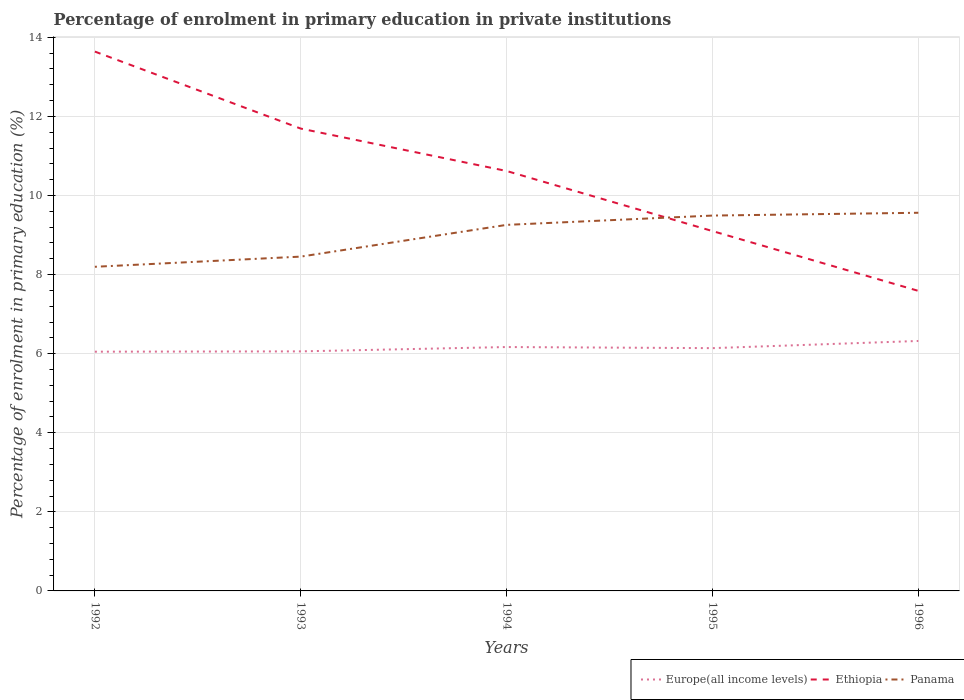Across all years, what is the maximum percentage of enrolment in primary education in Ethiopia?
Offer a terse response. 7.59. What is the total percentage of enrolment in primary education in Ethiopia in the graph?
Make the answer very short. 6.05. What is the difference between the highest and the second highest percentage of enrolment in primary education in Panama?
Your answer should be compact. 1.37. What is the difference between the highest and the lowest percentage of enrolment in primary education in Europe(all income levels)?
Your answer should be compact. 2. How many years are there in the graph?
Offer a very short reply. 5. Are the values on the major ticks of Y-axis written in scientific E-notation?
Your response must be concise. No. Does the graph contain grids?
Your answer should be compact. Yes. Where does the legend appear in the graph?
Keep it short and to the point. Bottom right. How are the legend labels stacked?
Offer a terse response. Horizontal. What is the title of the graph?
Provide a succinct answer. Percentage of enrolment in primary education in private institutions. What is the label or title of the Y-axis?
Keep it short and to the point. Percentage of enrolment in primary education (%). What is the Percentage of enrolment in primary education (%) in Europe(all income levels) in 1992?
Ensure brevity in your answer.  6.05. What is the Percentage of enrolment in primary education (%) in Ethiopia in 1992?
Your answer should be compact. 13.64. What is the Percentage of enrolment in primary education (%) in Panama in 1992?
Your answer should be compact. 8.2. What is the Percentage of enrolment in primary education (%) in Europe(all income levels) in 1993?
Your answer should be compact. 6.06. What is the Percentage of enrolment in primary education (%) of Ethiopia in 1993?
Keep it short and to the point. 11.69. What is the Percentage of enrolment in primary education (%) in Panama in 1993?
Ensure brevity in your answer.  8.45. What is the Percentage of enrolment in primary education (%) of Europe(all income levels) in 1994?
Your response must be concise. 6.17. What is the Percentage of enrolment in primary education (%) of Ethiopia in 1994?
Provide a succinct answer. 10.62. What is the Percentage of enrolment in primary education (%) of Panama in 1994?
Your answer should be compact. 9.26. What is the Percentage of enrolment in primary education (%) of Europe(all income levels) in 1995?
Make the answer very short. 6.14. What is the Percentage of enrolment in primary education (%) of Ethiopia in 1995?
Offer a very short reply. 9.1. What is the Percentage of enrolment in primary education (%) of Panama in 1995?
Provide a succinct answer. 9.49. What is the Percentage of enrolment in primary education (%) of Europe(all income levels) in 1996?
Your answer should be very brief. 6.32. What is the Percentage of enrolment in primary education (%) in Ethiopia in 1996?
Ensure brevity in your answer.  7.59. What is the Percentage of enrolment in primary education (%) in Panama in 1996?
Provide a succinct answer. 9.56. Across all years, what is the maximum Percentage of enrolment in primary education (%) of Europe(all income levels)?
Keep it short and to the point. 6.32. Across all years, what is the maximum Percentage of enrolment in primary education (%) in Ethiopia?
Offer a terse response. 13.64. Across all years, what is the maximum Percentage of enrolment in primary education (%) in Panama?
Offer a terse response. 9.56. Across all years, what is the minimum Percentage of enrolment in primary education (%) of Europe(all income levels)?
Provide a succinct answer. 6.05. Across all years, what is the minimum Percentage of enrolment in primary education (%) of Ethiopia?
Your answer should be very brief. 7.59. Across all years, what is the minimum Percentage of enrolment in primary education (%) in Panama?
Your response must be concise. 8.2. What is the total Percentage of enrolment in primary education (%) of Europe(all income levels) in the graph?
Your answer should be very brief. 30.74. What is the total Percentage of enrolment in primary education (%) in Ethiopia in the graph?
Ensure brevity in your answer.  52.64. What is the total Percentage of enrolment in primary education (%) in Panama in the graph?
Provide a succinct answer. 44.97. What is the difference between the Percentage of enrolment in primary education (%) of Europe(all income levels) in 1992 and that in 1993?
Give a very brief answer. -0.01. What is the difference between the Percentage of enrolment in primary education (%) in Ethiopia in 1992 and that in 1993?
Provide a short and direct response. 1.95. What is the difference between the Percentage of enrolment in primary education (%) in Panama in 1992 and that in 1993?
Give a very brief answer. -0.26. What is the difference between the Percentage of enrolment in primary education (%) in Europe(all income levels) in 1992 and that in 1994?
Your answer should be very brief. -0.12. What is the difference between the Percentage of enrolment in primary education (%) in Ethiopia in 1992 and that in 1994?
Offer a terse response. 3.02. What is the difference between the Percentage of enrolment in primary education (%) in Panama in 1992 and that in 1994?
Keep it short and to the point. -1.06. What is the difference between the Percentage of enrolment in primary education (%) in Europe(all income levels) in 1992 and that in 1995?
Provide a short and direct response. -0.09. What is the difference between the Percentage of enrolment in primary education (%) of Ethiopia in 1992 and that in 1995?
Your answer should be very brief. 4.54. What is the difference between the Percentage of enrolment in primary education (%) of Panama in 1992 and that in 1995?
Make the answer very short. -1.3. What is the difference between the Percentage of enrolment in primary education (%) of Europe(all income levels) in 1992 and that in 1996?
Provide a succinct answer. -0.27. What is the difference between the Percentage of enrolment in primary education (%) in Ethiopia in 1992 and that in 1996?
Offer a very short reply. 6.05. What is the difference between the Percentage of enrolment in primary education (%) in Panama in 1992 and that in 1996?
Your answer should be very brief. -1.37. What is the difference between the Percentage of enrolment in primary education (%) in Europe(all income levels) in 1993 and that in 1994?
Your response must be concise. -0.11. What is the difference between the Percentage of enrolment in primary education (%) in Ethiopia in 1993 and that in 1994?
Make the answer very short. 1.07. What is the difference between the Percentage of enrolment in primary education (%) in Panama in 1993 and that in 1994?
Your response must be concise. -0.8. What is the difference between the Percentage of enrolment in primary education (%) of Europe(all income levels) in 1993 and that in 1995?
Give a very brief answer. -0.08. What is the difference between the Percentage of enrolment in primary education (%) in Ethiopia in 1993 and that in 1995?
Provide a succinct answer. 2.59. What is the difference between the Percentage of enrolment in primary education (%) in Panama in 1993 and that in 1995?
Give a very brief answer. -1.04. What is the difference between the Percentage of enrolment in primary education (%) of Europe(all income levels) in 1993 and that in 1996?
Make the answer very short. -0.26. What is the difference between the Percentage of enrolment in primary education (%) of Ethiopia in 1993 and that in 1996?
Provide a short and direct response. 4.1. What is the difference between the Percentage of enrolment in primary education (%) of Panama in 1993 and that in 1996?
Your answer should be very brief. -1.11. What is the difference between the Percentage of enrolment in primary education (%) of Europe(all income levels) in 1994 and that in 1995?
Provide a short and direct response. 0.03. What is the difference between the Percentage of enrolment in primary education (%) in Ethiopia in 1994 and that in 1995?
Your answer should be compact. 1.52. What is the difference between the Percentage of enrolment in primary education (%) of Panama in 1994 and that in 1995?
Keep it short and to the point. -0.24. What is the difference between the Percentage of enrolment in primary education (%) of Europe(all income levels) in 1994 and that in 1996?
Offer a terse response. -0.15. What is the difference between the Percentage of enrolment in primary education (%) in Ethiopia in 1994 and that in 1996?
Your response must be concise. 3.03. What is the difference between the Percentage of enrolment in primary education (%) in Panama in 1994 and that in 1996?
Give a very brief answer. -0.31. What is the difference between the Percentage of enrolment in primary education (%) in Europe(all income levels) in 1995 and that in 1996?
Offer a very short reply. -0.18. What is the difference between the Percentage of enrolment in primary education (%) in Ethiopia in 1995 and that in 1996?
Keep it short and to the point. 1.51. What is the difference between the Percentage of enrolment in primary education (%) of Panama in 1995 and that in 1996?
Provide a short and direct response. -0.07. What is the difference between the Percentage of enrolment in primary education (%) of Europe(all income levels) in 1992 and the Percentage of enrolment in primary education (%) of Ethiopia in 1993?
Keep it short and to the point. -5.64. What is the difference between the Percentage of enrolment in primary education (%) in Europe(all income levels) in 1992 and the Percentage of enrolment in primary education (%) in Panama in 1993?
Keep it short and to the point. -2.4. What is the difference between the Percentage of enrolment in primary education (%) of Ethiopia in 1992 and the Percentage of enrolment in primary education (%) of Panama in 1993?
Offer a very short reply. 5.19. What is the difference between the Percentage of enrolment in primary education (%) of Europe(all income levels) in 1992 and the Percentage of enrolment in primary education (%) of Ethiopia in 1994?
Offer a terse response. -4.57. What is the difference between the Percentage of enrolment in primary education (%) of Europe(all income levels) in 1992 and the Percentage of enrolment in primary education (%) of Panama in 1994?
Keep it short and to the point. -3.21. What is the difference between the Percentage of enrolment in primary education (%) of Ethiopia in 1992 and the Percentage of enrolment in primary education (%) of Panama in 1994?
Provide a succinct answer. 4.38. What is the difference between the Percentage of enrolment in primary education (%) in Europe(all income levels) in 1992 and the Percentage of enrolment in primary education (%) in Ethiopia in 1995?
Ensure brevity in your answer.  -3.05. What is the difference between the Percentage of enrolment in primary education (%) in Europe(all income levels) in 1992 and the Percentage of enrolment in primary education (%) in Panama in 1995?
Offer a terse response. -3.44. What is the difference between the Percentage of enrolment in primary education (%) in Ethiopia in 1992 and the Percentage of enrolment in primary education (%) in Panama in 1995?
Give a very brief answer. 4.15. What is the difference between the Percentage of enrolment in primary education (%) of Europe(all income levels) in 1992 and the Percentage of enrolment in primary education (%) of Ethiopia in 1996?
Offer a very short reply. -1.54. What is the difference between the Percentage of enrolment in primary education (%) of Europe(all income levels) in 1992 and the Percentage of enrolment in primary education (%) of Panama in 1996?
Your response must be concise. -3.51. What is the difference between the Percentage of enrolment in primary education (%) in Ethiopia in 1992 and the Percentage of enrolment in primary education (%) in Panama in 1996?
Provide a succinct answer. 4.08. What is the difference between the Percentage of enrolment in primary education (%) in Europe(all income levels) in 1993 and the Percentage of enrolment in primary education (%) in Ethiopia in 1994?
Your response must be concise. -4.56. What is the difference between the Percentage of enrolment in primary education (%) of Europe(all income levels) in 1993 and the Percentage of enrolment in primary education (%) of Panama in 1994?
Offer a terse response. -3.2. What is the difference between the Percentage of enrolment in primary education (%) of Ethiopia in 1993 and the Percentage of enrolment in primary education (%) of Panama in 1994?
Give a very brief answer. 2.44. What is the difference between the Percentage of enrolment in primary education (%) of Europe(all income levels) in 1993 and the Percentage of enrolment in primary education (%) of Ethiopia in 1995?
Your answer should be compact. -3.04. What is the difference between the Percentage of enrolment in primary education (%) in Europe(all income levels) in 1993 and the Percentage of enrolment in primary education (%) in Panama in 1995?
Offer a terse response. -3.43. What is the difference between the Percentage of enrolment in primary education (%) in Ethiopia in 1993 and the Percentage of enrolment in primary education (%) in Panama in 1995?
Your response must be concise. 2.2. What is the difference between the Percentage of enrolment in primary education (%) in Europe(all income levels) in 1993 and the Percentage of enrolment in primary education (%) in Ethiopia in 1996?
Your answer should be very brief. -1.53. What is the difference between the Percentage of enrolment in primary education (%) of Europe(all income levels) in 1993 and the Percentage of enrolment in primary education (%) of Panama in 1996?
Give a very brief answer. -3.51. What is the difference between the Percentage of enrolment in primary education (%) of Ethiopia in 1993 and the Percentage of enrolment in primary education (%) of Panama in 1996?
Give a very brief answer. 2.13. What is the difference between the Percentage of enrolment in primary education (%) in Europe(all income levels) in 1994 and the Percentage of enrolment in primary education (%) in Ethiopia in 1995?
Offer a very short reply. -2.93. What is the difference between the Percentage of enrolment in primary education (%) of Europe(all income levels) in 1994 and the Percentage of enrolment in primary education (%) of Panama in 1995?
Your answer should be compact. -3.32. What is the difference between the Percentage of enrolment in primary education (%) in Ethiopia in 1994 and the Percentage of enrolment in primary education (%) in Panama in 1995?
Give a very brief answer. 1.13. What is the difference between the Percentage of enrolment in primary education (%) of Europe(all income levels) in 1994 and the Percentage of enrolment in primary education (%) of Ethiopia in 1996?
Keep it short and to the point. -1.42. What is the difference between the Percentage of enrolment in primary education (%) of Europe(all income levels) in 1994 and the Percentage of enrolment in primary education (%) of Panama in 1996?
Ensure brevity in your answer.  -3.4. What is the difference between the Percentage of enrolment in primary education (%) in Ethiopia in 1994 and the Percentage of enrolment in primary education (%) in Panama in 1996?
Your response must be concise. 1.06. What is the difference between the Percentage of enrolment in primary education (%) in Europe(all income levels) in 1995 and the Percentage of enrolment in primary education (%) in Ethiopia in 1996?
Offer a terse response. -1.45. What is the difference between the Percentage of enrolment in primary education (%) of Europe(all income levels) in 1995 and the Percentage of enrolment in primary education (%) of Panama in 1996?
Ensure brevity in your answer.  -3.42. What is the difference between the Percentage of enrolment in primary education (%) of Ethiopia in 1995 and the Percentage of enrolment in primary education (%) of Panama in 1996?
Ensure brevity in your answer.  -0.46. What is the average Percentage of enrolment in primary education (%) in Europe(all income levels) per year?
Your answer should be very brief. 6.15. What is the average Percentage of enrolment in primary education (%) of Ethiopia per year?
Ensure brevity in your answer.  10.53. What is the average Percentage of enrolment in primary education (%) in Panama per year?
Ensure brevity in your answer.  8.99. In the year 1992, what is the difference between the Percentage of enrolment in primary education (%) of Europe(all income levels) and Percentage of enrolment in primary education (%) of Ethiopia?
Ensure brevity in your answer.  -7.59. In the year 1992, what is the difference between the Percentage of enrolment in primary education (%) of Europe(all income levels) and Percentage of enrolment in primary education (%) of Panama?
Ensure brevity in your answer.  -2.15. In the year 1992, what is the difference between the Percentage of enrolment in primary education (%) of Ethiopia and Percentage of enrolment in primary education (%) of Panama?
Ensure brevity in your answer.  5.44. In the year 1993, what is the difference between the Percentage of enrolment in primary education (%) of Europe(all income levels) and Percentage of enrolment in primary education (%) of Ethiopia?
Your answer should be very brief. -5.63. In the year 1993, what is the difference between the Percentage of enrolment in primary education (%) of Europe(all income levels) and Percentage of enrolment in primary education (%) of Panama?
Offer a very short reply. -2.4. In the year 1993, what is the difference between the Percentage of enrolment in primary education (%) of Ethiopia and Percentage of enrolment in primary education (%) of Panama?
Provide a succinct answer. 3.24. In the year 1994, what is the difference between the Percentage of enrolment in primary education (%) in Europe(all income levels) and Percentage of enrolment in primary education (%) in Ethiopia?
Make the answer very short. -4.45. In the year 1994, what is the difference between the Percentage of enrolment in primary education (%) of Europe(all income levels) and Percentage of enrolment in primary education (%) of Panama?
Give a very brief answer. -3.09. In the year 1994, what is the difference between the Percentage of enrolment in primary education (%) of Ethiopia and Percentage of enrolment in primary education (%) of Panama?
Offer a very short reply. 1.36. In the year 1995, what is the difference between the Percentage of enrolment in primary education (%) in Europe(all income levels) and Percentage of enrolment in primary education (%) in Ethiopia?
Your response must be concise. -2.96. In the year 1995, what is the difference between the Percentage of enrolment in primary education (%) of Europe(all income levels) and Percentage of enrolment in primary education (%) of Panama?
Ensure brevity in your answer.  -3.35. In the year 1995, what is the difference between the Percentage of enrolment in primary education (%) of Ethiopia and Percentage of enrolment in primary education (%) of Panama?
Provide a short and direct response. -0.39. In the year 1996, what is the difference between the Percentage of enrolment in primary education (%) in Europe(all income levels) and Percentage of enrolment in primary education (%) in Ethiopia?
Offer a terse response. -1.27. In the year 1996, what is the difference between the Percentage of enrolment in primary education (%) of Europe(all income levels) and Percentage of enrolment in primary education (%) of Panama?
Your answer should be very brief. -3.24. In the year 1996, what is the difference between the Percentage of enrolment in primary education (%) in Ethiopia and Percentage of enrolment in primary education (%) in Panama?
Keep it short and to the point. -1.98. What is the ratio of the Percentage of enrolment in primary education (%) of Ethiopia in 1992 to that in 1993?
Provide a succinct answer. 1.17. What is the ratio of the Percentage of enrolment in primary education (%) in Panama in 1992 to that in 1993?
Ensure brevity in your answer.  0.97. What is the ratio of the Percentage of enrolment in primary education (%) in Europe(all income levels) in 1992 to that in 1994?
Offer a terse response. 0.98. What is the ratio of the Percentage of enrolment in primary education (%) of Ethiopia in 1992 to that in 1994?
Your response must be concise. 1.28. What is the ratio of the Percentage of enrolment in primary education (%) in Panama in 1992 to that in 1994?
Give a very brief answer. 0.89. What is the ratio of the Percentage of enrolment in primary education (%) of Europe(all income levels) in 1992 to that in 1995?
Your response must be concise. 0.99. What is the ratio of the Percentage of enrolment in primary education (%) of Ethiopia in 1992 to that in 1995?
Provide a short and direct response. 1.5. What is the ratio of the Percentage of enrolment in primary education (%) of Panama in 1992 to that in 1995?
Provide a succinct answer. 0.86. What is the ratio of the Percentage of enrolment in primary education (%) in Europe(all income levels) in 1992 to that in 1996?
Offer a very short reply. 0.96. What is the ratio of the Percentage of enrolment in primary education (%) in Ethiopia in 1992 to that in 1996?
Provide a short and direct response. 1.8. What is the ratio of the Percentage of enrolment in primary education (%) in Panama in 1992 to that in 1996?
Provide a short and direct response. 0.86. What is the ratio of the Percentage of enrolment in primary education (%) of Europe(all income levels) in 1993 to that in 1994?
Your answer should be compact. 0.98. What is the ratio of the Percentage of enrolment in primary education (%) of Ethiopia in 1993 to that in 1994?
Provide a short and direct response. 1.1. What is the ratio of the Percentage of enrolment in primary education (%) of Panama in 1993 to that in 1994?
Your answer should be very brief. 0.91. What is the ratio of the Percentage of enrolment in primary education (%) in Europe(all income levels) in 1993 to that in 1995?
Keep it short and to the point. 0.99. What is the ratio of the Percentage of enrolment in primary education (%) of Ethiopia in 1993 to that in 1995?
Offer a terse response. 1.28. What is the ratio of the Percentage of enrolment in primary education (%) of Panama in 1993 to that in 1995?
Offer a terse response. 0.89. What is the ratio of the Percentage of enrolment in primary education (%) in Europe(all income levels) in 1993 to that in 1996?
Offer a very short reply. 0.96. What is the ratio of the Percentage of enrolment in primary education (%) of Ethiopia in 1993 to that in 1996?
Your response must be concise. 1.54. What is the ratio of the Percentage of enrolment in primary education (%) in Panama in 1993 to that in 1996?
Your answer should be compact. 0.88. What is the ratio of the Percentage of enrolment in primary education (%) of Europe(all income levels) in 1994 to that in 1995?
Keep it short and to the point. 1. What is the ratio of the Percentage of enrolment in primary education (%) in Ethiopia in 1994 to that in 1995?
Provide a short and direct response. 1.17. What is the ratio of the Percentage of enrolment in primary education (%) of Panama in 1994 to that in 1995?
Make the answer very short. 0.98. What is the ratio of the Percentage of enrolment in primary education (%) of Europe(all income levels) in 1994 to that in 1996?
Your answer should be very brief. 0.98. What is the ratio of the Percentage of enrolment in primary education (%) of Ethiopia in 1994 to that in 1996?
Provide a short and direct response. 1.4. What is the ratio of the Percentage of enrolment in primary education (%) of Europe(all income levels) in 1995 to that in 1996?
Offer a very short reply. 0.97. What is the ratio of the Percentage of enrolment in primary education (%) in Ethiopia in 1995 to that in 1996?
Ensure brevity in your answer.  1.2. What is the difference between the highest and the second highest Percentage of enrolment in primary education (%) in Europe(all income levels)?
Offer a terse response. 0.15. What is the difference between the highest and the second highest Percentage of enrolment in primary education (%) in Ethiopia?
Keep it short and to the point. 1.95. What is the difference between the highest and the second highest Percentage of enrolment in primary education (%) in Panama?
Your response must be concise. 0.07. What is the difference between the highest and the lowest Percentage of enrolment in primary education (%) of Europe(all income levels)?
Provide a short and direct response. 0.27. What is the difference between the highest and the lowest Percentage of enrolment in primary education (%) in Ethiopia?
Provide a succinct answer. 6.05. What is the difference between the highest and the lowest Percentage of enrolment in primary education (%) of Panama?
Your answer should be very brief. 1.37. 